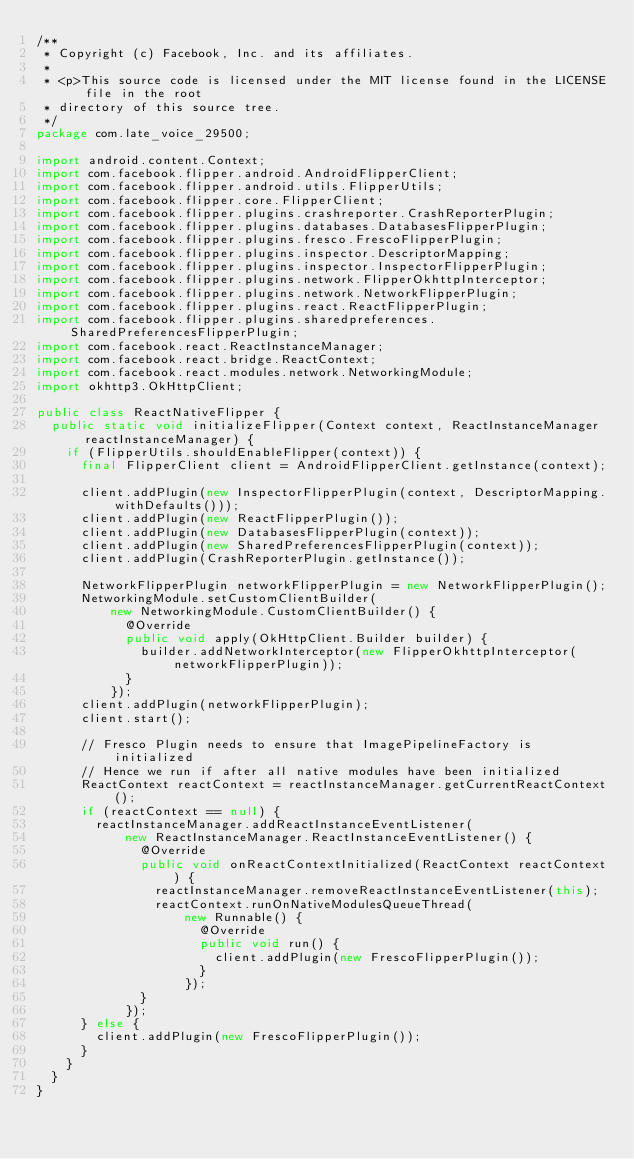Convert code to text. <code><loc_0><loc_0><loc_500><loc_500><_Java_>/**
 * Copyright (c) Facebook, Inc. and its affiliates.
 *
 * <p>This source code is licensed under the MIT license found in the LICENSE file in the root
 * directory of this source tree.
 */
package com.late_voice_29500;

import android.content.Context;
import com.facebook.flipper.android.AndroidFlipperClient;
import com.facebook.flipper.android.utils.FlipperUtils;
import com.facebook.flipper.core.FlipperClient;
import com.facebook.flipper.plugins.crashreporter.CrashReporterPlugin;
import com.facebook.flipper.plugins.databases.DatabasesFlipperPlugin;
import com.facebook.flipper.plugins.fresco.FrescoFlipperPlugin;
import com.facebook.flipper.plugins.inspector.DescriptorMapping;
import com.facebook.flipper.plugins.inspector.InspectorFlipperPlugin;
import com.facebook.flipper.plugins.network.FlipperOkhttpInterceptor;
import com.facebook.flipper.plugins.network.NetworkFlipperPlugin;
import com.facebook.flipper.plugins.react.ReactFlipperPlugin;
import com.facebook.flipper.plugins.sharedpreferences.SharedPreferencesFlipperPlugin;
import com.facebook.react.ReactInstanceManager;
import com.facebook.react.bridge.ReactContext;
import com.facebook.react.modules.network.NetworkingModule;
import okhttp3.OkHttpClient;

public class ReactNativeFlipper {
  public static void initializeFlipper(Context context, ReactInstanceManager reactInstanceManager) {
    if (FlipperUtils.shouldEnableFlipper(context)) {
      final FlipperClient client = AndroidFlipperClient.getInstance(context);

      client.addPlugin(new InspectorFlipperPlugin(context, DescriptorMapping.withDefaults()));
      client.addPlugin(new ReactFlipperPlugin());
      client.addPlugin(new DatabasesFlipperPlugin(context));
      client.addPlugin(new SharedPreferencesFlipperPlugin(context));
      client.addPlugin(CrashReporterPlugin.getInstance());

      NetworkFlipperPlugin networkFlipperPlugin = new NetworkFlipperPlugin();
      NetworkingModule.setCustomClientBuilder(
          new NetworkingModule.CustomClientBuilder() {
            @Override
            public void apply(OkHttpClient.Builder builder) {
              builder.addNetworkInterceptor(new FlipperOkhttpInterceptor(networkFlipperPlugin));
            }
          });
      client.addPlugin(networkFlipperPlugin);
      client.start();

      // Fresco Plugin needs to ensure that ImagePipelineFactory is initialized
      // Hence we run if after all native modules have been initialized
      ReactContext reactContext = reactInstanceManager.getCurrentReactContext();
      if (reactContext == null) {
        reactInstanceManager.addReactInstanceEventListener(
            new ReactInstanceManager.ReactInstanceEventListener() {
              @Override
              public void onReactContextInitialized(ReactContext reactContext) {
                reactInstanceManager.removeReactInstanceEventListener(this);
                reactContext.runOnNativeModulesQueueThread(
                    new Runnable() {
                      @Override
                      public void run() {
                        client.addPlugin(new FrescoFlipperPlugin());
                      }
                    });
              }
            });
      } else {
        client.addPlugin(new FrescoFlipperPlugin());
      }
    }
  }
}
</code> 